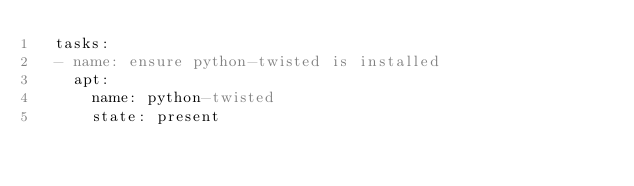<code> <loc_0><loc_0><loc_500><loc_500><_YAML_>  tasks:
  - name: ensure python-twisted is installed
    apt:
      name: python-twisted
      state: present
</code> 